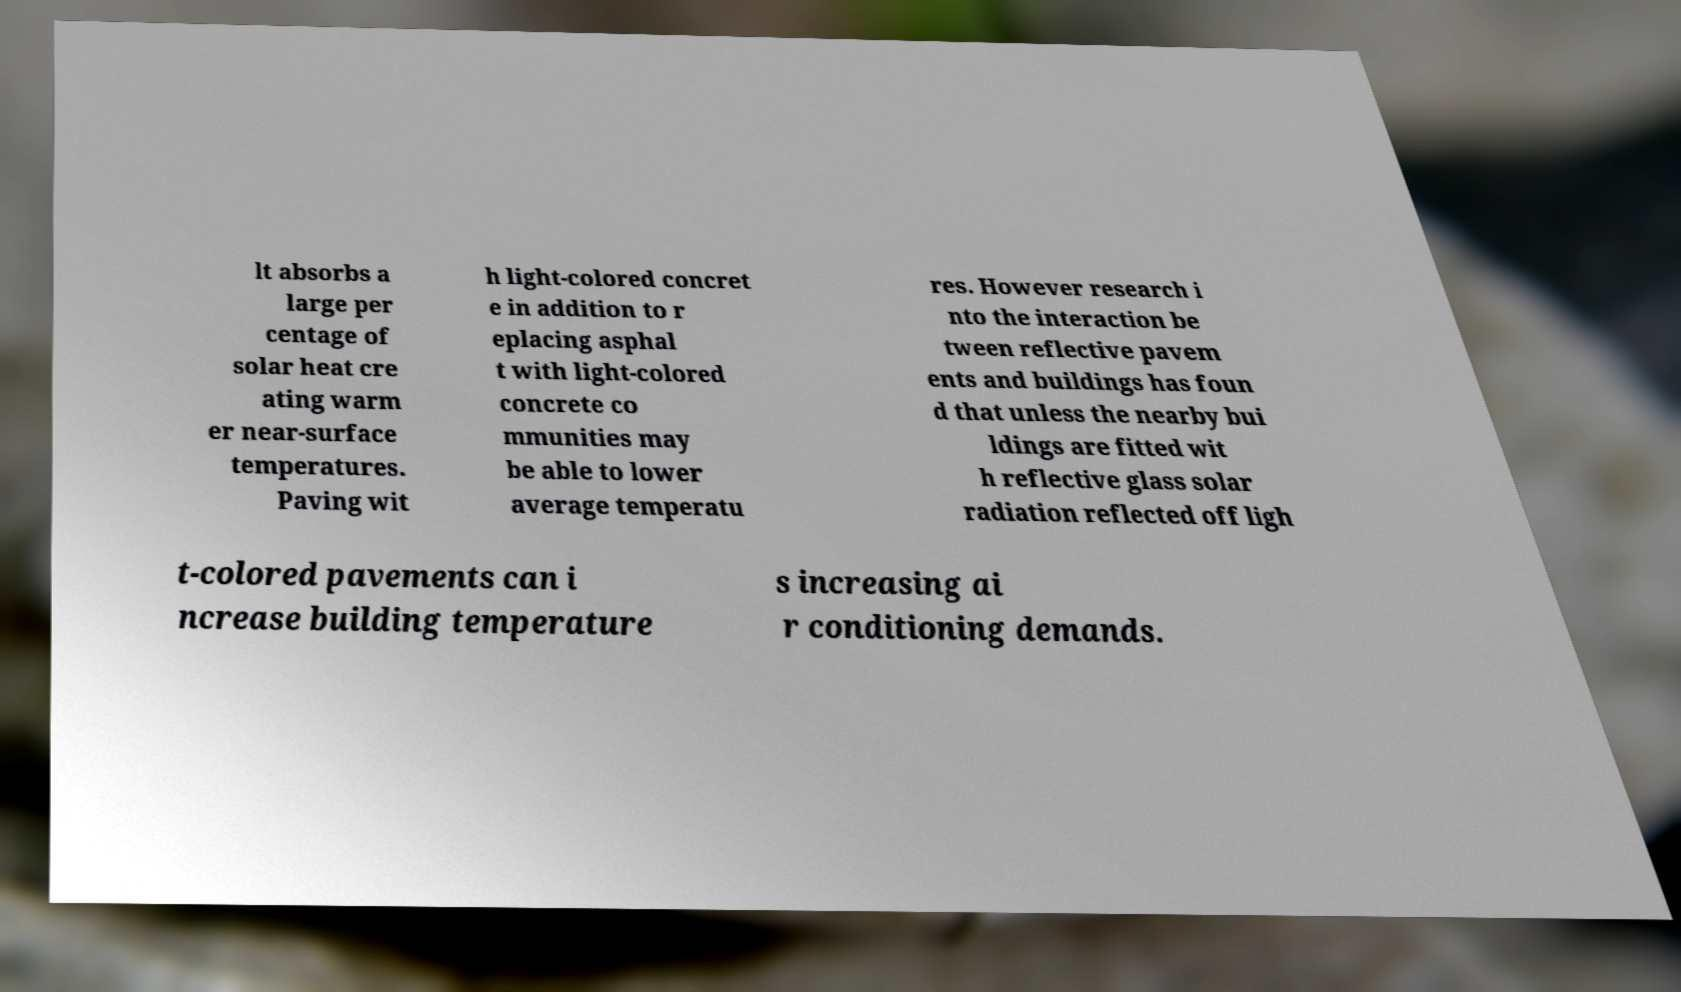Please identify and transcribe the text found in this image. lt absorbs a large per centage of solar heat cre ating warm er near-surface temperatures. Paving wit h light-colored concret e in addition to r eplacing asphal t with light-colored concrete co mmunities may be able to lower average temperatu res. However research i nto the interaction be tween reflective pavem ents and buildings has foun d that unless the nearby bui ldings are fitted wit h reflective glass solar radiation reflected off ligh t-colored pavements can i ncrease building temperature s increasing ai r conditioning demands. 